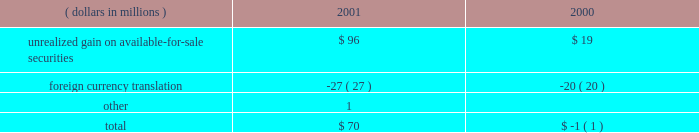A black-scholes option-pricing model was used for purposes of estimating the fair value of state street 2019s employee stock options at the grant date .
The following were the weighted average assumptions for the years ended december 31 , 2001 , 2000 and 1999 , respectively : risk-free interest rates of 3.99% ( 3.99 % ) , 5.75% ( 5.75 % ) and 5.90% ( 5.90 % ) ; dividend yields of 1.08% ( 1.08 % ) , .73% ( .73 % ) and .92% ( .92 % ) ; and volatility factors of the expected market price of state street common stock of .30 , .30 and .30 .
The estimated weighted average life of the stock options granted was 4.1 years for the years ended december 31 , 2001 , 2000 and 1999 .
O t h e r u n r e a l i z e d c o m p r e h e n s i v e i n c o m e ( l o s s ) at december 31 , the components of other unrealized comprehensive income ( loss ) , net of related taxes , were as follows: .
Note j shareholders 2019 rights plan in 1988 , state street declared a dividend of one preferred share purchase right for each outstanding share of common stock .
In 1998 , the rights agreement was amended and restated , and in 2001 , the rights plan was impacted by the 2-for-1 stock split .
Accordingly , a right may be exercised , under certain conditions , to purchase one eight-hundredths share of a series of participating preferred stock at an exercise price of $ 132.50 , subject to adjustment .
The rights become exercisable if a party acquires or obtains the right to acquire 10% ( 10 % ) or more of state street 2019s common stock or after commencement or public announcement of an offer for 10% ( 10 % ) or more of state street 2019s common stock .
When exercisable , under certain conditions , each right entitles the holder thereof to purchase shares of common stock , of either state street or of the acquirer , having a market value of two times the then-current exercise price of that right .
The rights expire in september 2008 , and may be redeemed at a price of $ .00125 per right , subject to adjustment , at any time prior to expiration or the acquisition of 10% ( 10 % ) of state street 2019s common stock .
Under certain circumstances , the rights may be redeemed after they become exercisable and may be subject to automatic redemption .
Note k regulatory matters r e g u l a t o r y c a p i t a l state street is subject to various regulatory capital requirements administered by federal banking agencies .
Failure to meet minimum capital requirements can initiate certain mandatory and discretionary actions by regulators that , if undertaken , could have a direct material effect on state street 2019s financial condition .
Under capital adequacy guidelines , state street must meet specific capital guidelines that involve quantitative measures of state street 2019s assets , liabilities and off-balance sheet items as calculated under regulatory accounting practices .
State street 2019s capital amounts and classification are subject to qualitative judgments by the regulators about components , risk weightings and other factors .
42 state street corporation .
What is the net change in the balance of the other unrealized comprehensive income in 2001? 
Computations: (70 - -1)
Answer: 71.0. 